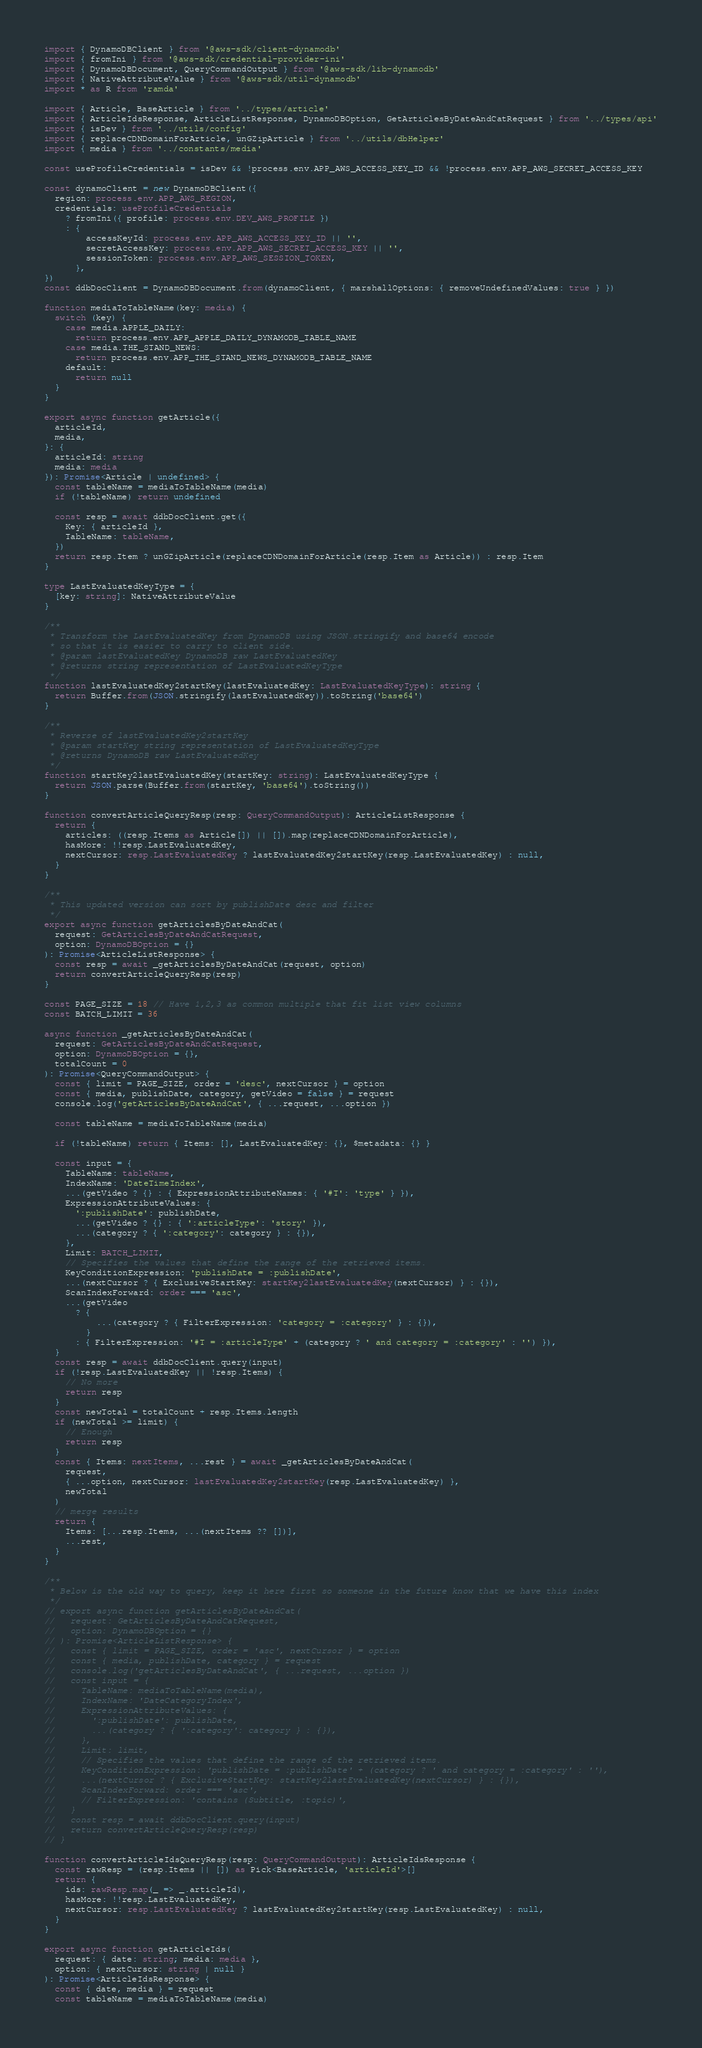<code> <loc_0><loc_0><loc_500><loc_500><_TypeScript_>import { DynamoDBClient } from '@aws-sdk/client-dynamodb'
import { fromIni } from '@aws-sdk/credential-provider-ini'
import { DynamoDBDocument, QueryCommandOutput } from '@aws-sdk/lib-dynamodb'
import { NativeAttributeValue } from '@aws-sdk/util-dynamodb'
import * as R from 'ramda'

import { Article, BaseArticle } from '../types/article'
import { ArticleIdsResponse, ArticleListResponse, DynamoDBOption, GetArticlesByDateAndCatRequest } from '../types/api'
import { isDev } from '../utils/config'
import { replaceCDNDomainForArticle, unGZipArticle } from '../utils/dbHelper'
import { media } from '../constants/media'

const useProfileCredentials = isDev && !process.env.APP_AWS_ACCESS_KEY_ID && !process.env.APP_AWS_SECRET_ACCESS_KEY

const dynamoClient = new DynamoDBClient({
  region: process.env.APP_AWS_REGION,
  credentials: useProfileCredentials
    ? fromIni({ profile: process.env.DEV_AWS_PROFILE })
    : {
        accessKeyId: process.env.APP_AWS_ACCESS_KEY_ID || '',
        secretAccessKey: process.env.APP_AWS_SECRET_ACCESS_KEY || '',
        sessionToken: process.env.APP_AWS_SESSION_TOKEN,
      },
})
const ddbDocClient = DynamoDBDocument.from(dynamoClient, { marshallOptions: { removeUndefinedValues: true } })

function mediaToTableName(key: media) {
  switch (key) {
    case media.APPLE_DAILY:
      return process.env.APP_APPLE_DAILY_DYNAMODB_TABLE_NAME
    case media.THE_STAND_NEWS:
      return process.env.APP_THE_STAND_NEWS_DYNAMODB_TABLE_NAME
    default:
      return null
  }
}

export async function getArticle({
  articleId,
  media,
}: {
  articleId: string
  media: media
}): Promise<Article | undefined> {
  const tableName = mediaToTableName(media)
  if (!tableName) return undefined

  const resp = await ddbDocClient.get({
    Key: { articleId },
    TableName: tableName,
  })
  return resp.Item ? unGZipArticle(replaceCDNDomainForArticle(resp.Item as Article)) : resp.Item
}

type LastEvaluatedKeyType = {
  [key: string]: NativeAttributeValue
}

/**
 * Transform the LastEvaluatedKey from DynamoDB using JSON.stringify and base64 encode
 * so that it is easier to carry to client side.
 * @param lastEvaluatedKey DynamoDB raw LastEvaluatedKey
 * @returns string representation of LastEvaluatedKeyType
 */
function lastEvaluatedKey2startKey(lastEvaluatedKey: LastEvaluatedKeyType): string {
  return Buffer.from(JSON.stringify(lastEvaluatedKey)).toString('base64')
}

/**
 * Reverse of lastEvaluatedKey2startKey
 * @param startKey string representation of LastEvaluatedKeyType
 * @returns DynamoDB raw LastEvaluatedKey
 */
function startKey2lastEvaluatedKey(startKey: string): LastEvaluatedKeyType {
  return JSON.parse(Buffer.from(startKey, 'base64').toString())
}

function convertArticleQueryResp(resp: QueryCommandOutput): ArticleListResponse {
  return {
    articles: ((resp.Items as Article[]) || []).map(replaceCDNDomainForArticle),
    hasMore: !!resp.LastEvaluatedKey,
    nextCursor: resp.LastEvaluatedKey ? lastEvaluatedKey2startKey(resp.LastEvaluatedKey) : null,
  }
}

/**
 * This updated version can sort by publishDate desc and filter
 */
export async function getArticlesByDateAndCat(
  request: GetArticlesByDateAndCatRequest,
  option: DynamoDBOption = {}
): Promise<ArticleListResponse> {
  const resp = await _getArticlesByDateAndCat(request, option)
  return convertArticleQueryResp(resp)
}

const PAGE_SIZE = 18 // Have 1,2,3 as common multiple that fit list view columns
const BATCH_LIMIT = 36

async function _getArticlesByDateAndCat(
  request: GetArticlesByDateAndCatRequest,
  option: DynamoDBOption = {},
  totalCount = 0
): Promise<QueryCommandOutput> {
  const { limit = PAGE_SIZE, order = 'desc', nextCursor } = option
  const { media, publishDate, category, getVideo = false } = request
  console.log('getArticlesByDateAndCat', { ...request, ...option })

  const tableName = mediaToTableName(media)

  if (!tableName) return { Items: [], LastEvaluatedKey: {}, $metadata: {} }

  const input = {
    TableName: tableName,
    IndexName: 'DateTimeIndex',
    ...(getVideo ? {} : { ExpressionAttributeNames: { '#T': 'type' } }),
    ExpressionAttributeValues: {
      ':publishDate': publishDate,
      ...(getVideo ? {} : { ':articleType': 'story' }),
      ...(category ? { ':category': category } : {}),
    },
    Limit: BATCH_LIMIT,
    // Specifies the values that define the range of the retrieved items.
    KeyConditionExpression: 'publishDate = :publishDate',
    ...(nextCursor ? { ExclusiveStartKey: startKey2lastEvaluatedKey(nextCursor) } : {}),
    ScanIndexForward: order === 'asc',
    ...(getVideo
      ? {
          ...(category ? { FilterExpression: 'category = :category' } : {}),
        }
      : { FilterExpression: '#T = :articleType' + (category ? ' and category = :category' : '') }),
  }
  const resp = await ddbDocClient.query(input)
  if (!resp.LastEvaluatedKey || !resp.Items) {
    // No more
    return resp
  }
  const newTotal = totalCount + resp.Items.length
  if (newTotal >= limit) {
    // Enough
    return resp
  }
  const { Items: nextItems, ...rest } = await _getArticlesByDateAndCat(
    request,
    { ...option, nextCursor: lastEvaluatedKey2startKey(resp.LastEvaluatedKey) },
    newTotal
  )
  // merge results
  return {
    Items: [...resp.Items, ...(nextItems ?? [])],
    ...rest,
  }
}

/**
 * Below is the old way to query, keep it here first so someone in the future know that we have this index
 */
// export async function getArticlesByDateAndCat(
//   request: GetArticlesByDateAndCatRequest,
//   option: DynamoDBOption = {}
// ): Promise<ArticleListResponse> {
//   const { limit = PAGE_SIZE, order = 'asc', nextCursor } = option
//   const { media, publishDate, category } = request
//   console.log('getArticlesByDateAndCat', { ...request, ...option })
//   const input = {
//     TableName: mediaToTableName(media),
//     IndexName: 'DateCategoryIndex',
//     ExpressionAttributeValues: {
//       ':publishDate': publishDate,
//       ...(category ? { ':category': category } : {}),
//     },
//     Limit: limit,
//     // Specifies the values that define the range of the retrieved items.
//     KeyConditionExpression: 'publishDate = :publishDate' + (category ? ' and category = :category' : ''),
//     ...(nextCursor ? { ExclusiveStartKey: startKey2lastEvaluatedKey(nextCursor) } : {}),
//     ScanIndexForward: order === 'asc',
//     // FilterExpression: 'contains (Subtitle, :topic)',
//   }
//   const resp = await ddbDocClient.query(input)
//   return convertArticleQueryResp(resp)
// }

function convertArticleIdsQueryResp(resp: QueryCommandOutput): ArticleIdsResponse {
  const rawResp = (resp.Items || []) as Pick<BaseArticle, 'articleId'>[]
  return {
    ids: rawResp.map(_ => _.articleId),
    hasMore: !!resp.LastEvaluatedKey,
    nextCursor: resp.LastEvaluatedKey ? lastEvaluatedKey2startKey(resp.LastEvaluatedKey) : null,
  }
}

export async function getArticleIds(
  request: { date: string; media: media },
  option: { nextCursor: string | null }
): Promise<ArticleIdsResponse> {
  const { date, media } = request
  const tableName = mediaToTableName(media)</code> 